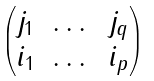<formula> <loc_0><loc_0><loc_500><loc_500>\begin{pmatrix} j _ { 1 } & \dots & j _ { q } \\ i _ { 1 } & \dots & i _ { p } \end{pmatrix}</formula> 